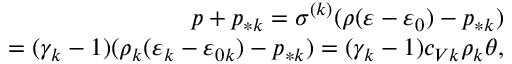Convert formula to latex. <formula><loc_0><loc_0><loc_500><loc_500>\begin{array} { r } { p + p _ { * k } = \sigma ^ { ( k ) } ( \rho ( \varepsilon - \varepsilon _ { 0 } ) - p _ { * k } ) } \\ { = ( \gamma _ { k } - 1 ) ( \rho _ { k } ( \varepsilon _ { k } - \varepsilon _ { 0 k } ) - p _ { * k } ) = ( \gamma _ { k } - 1 ) c _ { V k } \rho _ { k } \theta , } \end{array}</formula> 